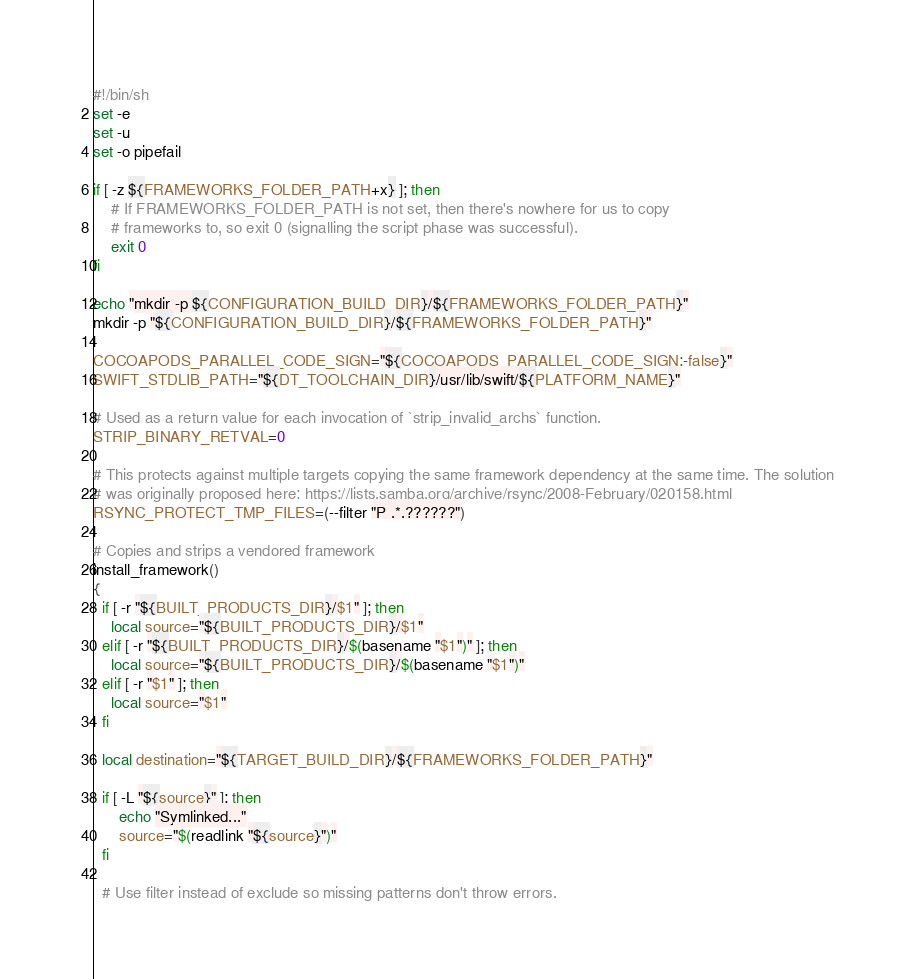<code> <loc_0><loc_0><loc_500><loc_500><_Bash_>#!/bin/sh
set -e
set -u
set -o pipefail

if [ -z ${FRAMEWORKS_FOLDER_PATH+x} ]; then
    # If FRAMEWORKS_FOLDER_PATH is not set, then there's nowhere for us to copy
    # frameworks to, so exit 0 (signalling the script phase was successful).
    exit 0
fi

echo "mkdir -p ${CONFIGURATION_BUILD_DIR}/${FRAMEWORKS_FOLDER_PATH}"
mkdir -p "${CONFIGURATION_BUILD_DIR}/${FRAMEWORKS_FOLDER_PATH}"

COCOAPODS_PARALLEL_CODE_SIGN="${COCOAPODS_PARALLEL_CODE_SIGN:-false}"
SWIFT_STDLIB_PATH="${DT_TOOLCHAIN_DIR}/usr/lib/swift/${PLATFORM_NAME}"

# Used as a return value for each invocation of `strip_invalid_archs` function.
STRIP_BINARY_RETVAL=0

# This protects against multiple targets copying the same framework dependency at the same time. The solution
# was originally proposed here: https://lists.samba.org/archive/rsync/2008-February/020158.html
RSYNC_PROTECT_TMP_FILES=(--filter "P .*.??????")

# Copies and strips a vendored framework
install_framework()
{
  if [ -r "${BUILT_PRODUCTS_DIR}/$1" ]; then
    local source="${BUILT_PRODUCTS_DIR}/$1"
  elif [ -r "${BUILT_PRODUCTS_DIR}/$(basename "$1")" ]; then
    local source="${BUILT_PRODUCTS_DIR}/$(basename "$1")"
  elif [ -r "$1" ]; then
    local source="$1"
  fi

  local destination="${TARGET_BUILD_DIR}/${FRAMEWORKS_FOLDER_PATH}"

  if [ -L "${source}" ]; then
      echo "Symlinked..."
      source="$(readlink "${source}")"
  fi

  # Use filter instead of exclude so missing patterns don't throw errors.</code> 